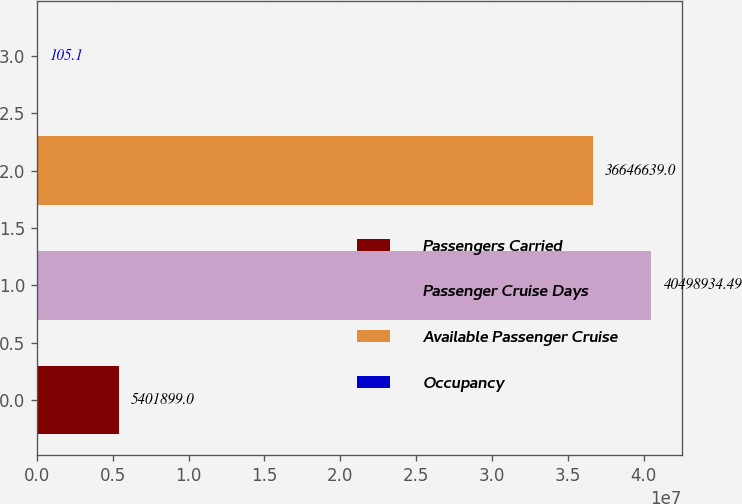<chart> <loc_0><loc_0><loc_500><loc_500><bar_chart><fcel>Passengers Carried<fcel>Passenger Cruise Days<fcel>Available Passenger Cruise<fcel>Occupancy<nl><fcel>5.4019e+06<fcel>4.04989e+07<fcel>3.66466e+07<fcel>105.1<nl></chart> 